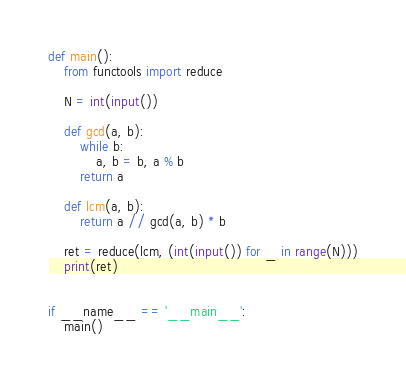Convert code to text. <code><loc_0><loc_0><loc_500><loc_500><_Python_>def main():
    from functools import reduce

    N = int(input())

    def gcd(a, b):
        while b:
            a, b = b, a % b
        return a

    def lcm(a, b):
        return a // gcd(a, b) * b

    ret = reduce(lcm, (int(input()) for _ in range(N)))
    print(ret)


if __name__ == '__main__':
    main()
</code> 